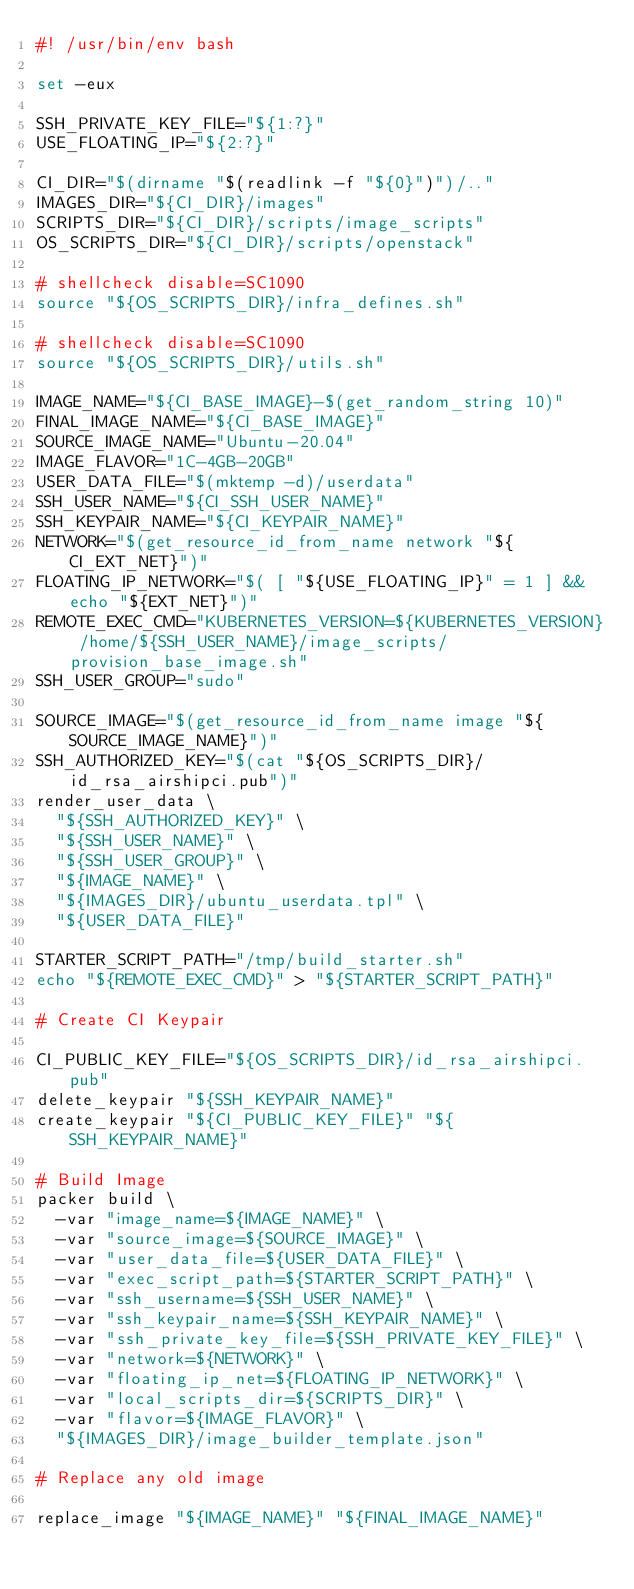<code> <loc_0><loc_0><loc_500><loc_500><_Bash_>#! /usr/bin/env bash

set -eux

SSH_PRIVATE_KEY_FILE="${1:?}"
USE_FLOATING_IP="${2:?}"

CI_DIR="$(dirname "$(readlink -f "${0}")")/.."
IMAGES_DIR="${CI_DIR}/images"
SCRIPTS_DIR="${CI_DIR}/scripts/image_scripts"
OS_SCRIPTS_DIR="${CI_DIR}/scripts/openstack"

# shellcheck disable=SC1090
source "${OS_SCRIPTS_DIR}/infra_defines.sh"

# shellcheck disable=SC1090
source "${OS_SCRIPTS_DIR}/utils.sh"

IMAGE_NAME="${CI_BASE_IMAGE}-$(get_random_string 10)"
FINAL_IMAGE_NAME="${CI_BASE_IMAGE}"
SOURCE_IMAGE_NAME="Ubuntu-20.04"
IMAGE_FLAVOR="1C-4GB-20GB"
USER_DATA_FILE="$(mktemp -d)/userdata"
SSH_USER_NAME="${CI_SSH_USER_NAME}"
SSH_KEYPAIR_NAME="${CI_KEYPAIR_NAME}"
NETWORK="$(get_resource_id_from_name network "${CI_EXT_NET}")"
FLOATING_IP_NETWORK="$( [ "${USE_FLOATING_IP}" = 1 ] && echo "${EXT_NET}")"
REMOTE_EXEC_CMD="KUBERNETES_VERSION=${KUBERNETES_VERSION} /home/${SSH_USER_NAME}/image_scripts/provision_base_image.sh"
SSH_USER_GROUP="sudo"

SOURCE_IMAGE="$(get_resource_id_from_name image "${SOURCE_IMAGE_NAME}")"
SSH_AUTHORIZED_KEY="$(cat "${OS_SCRIPTS_DIR}/id_rsa_airshipci.pub")"
render_user_data \
  "${SSH_AUTHORIZED_KEY}" \
  "${SSH_USER_NAME}" \
  "${SSH_USER_GROUP}" \
  "${IMAGE_NAME}" \
  "${IMAGES_DIR}/ubuntu_userdata.tpl" \
  "${USER_DATA_FILE}"

STARTER_SCRIPT_PATH="/tmp/build_starter.sh"
echo "${REMOTE_EXEC_CMD}" > "${STARTER_SCRIPT_PATH}"

# Create CI Keypair

CI_PUBLIC_KEY_FILE="${OS_SCRIPTS_DIR}/id_rsa_airshipci.pub"
delete_keypair "${SSH_KEYPAIR_NAME}"
create_keypair "${CI_PUBLIC_KEY_FILE}" "${SSH_KEYPAIR_NAME}"

# Build Image
packer build \
  -var "image_name=${IMAGE_NAME}" \
  -var "source_image=${SOURCE_IMAGE}" \
  -var "user_data_file=${USER_DATA_FILE}" \
  -var "exec_script_path=${STARTER_SCRIPT_PATH}" \
  -var "ssh_username=${SSH_USER_NAME}" \
  -var "ssh_keypair_name=${SSH_KEYPAIR_NAME}" \
  -var "ssh_private_key_file=${SSH_PRIVATE_KEY_FILE}" \
  -var "network=${NETWORK}" \
  -var "floating_ip_net=${FLOATING_IP_NETWORK}" \
  -var "local_scripts_dir=${SCRIPTS_DIR}" \
  -var "flavor=${IMAGE_FLAVOR}" \
  "${IMAGES_DIR}/image_builder_template.json"

# Replace any old image

replace_image "${IMAGE_NAME}" "${FINAL_IMAGE_NAME}"
</code> 